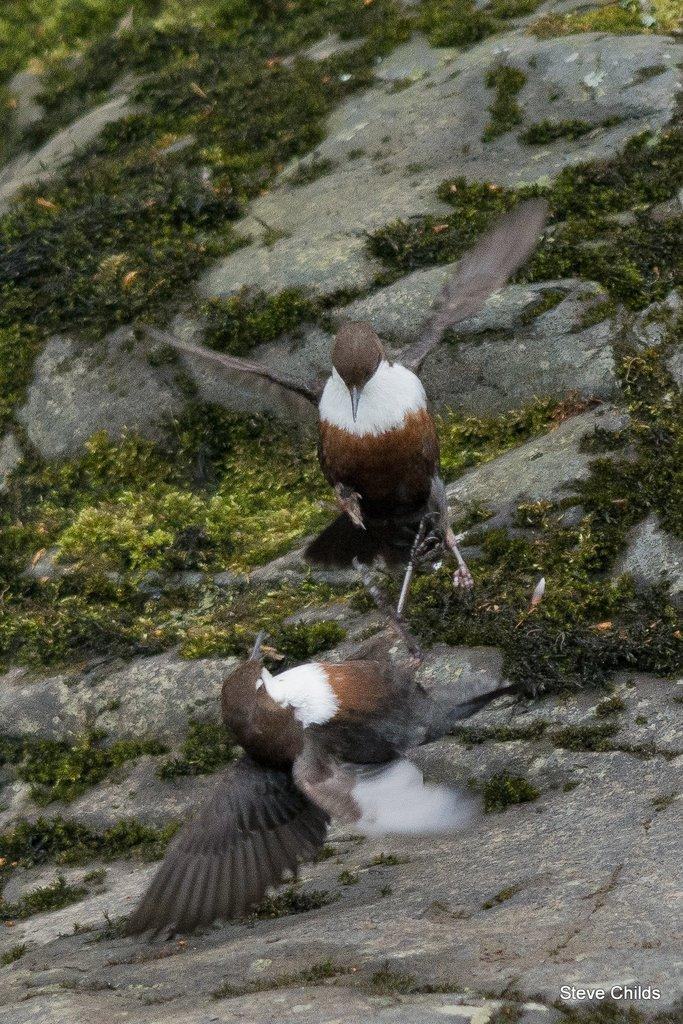What type of natural landscape can be seen in the image? There are mountains in the image. What type of vegetation can be found in the image? There is a thicket in the image. What type of animals are visible in the image? Birds are visible in the image. Is there any text or marking in the image? There is a watermark in the bottom right corner of the image. Can you see any caves in the image? There is no mention of caves in the provided facts, and therefore we cannot determine if any are present in the image. 